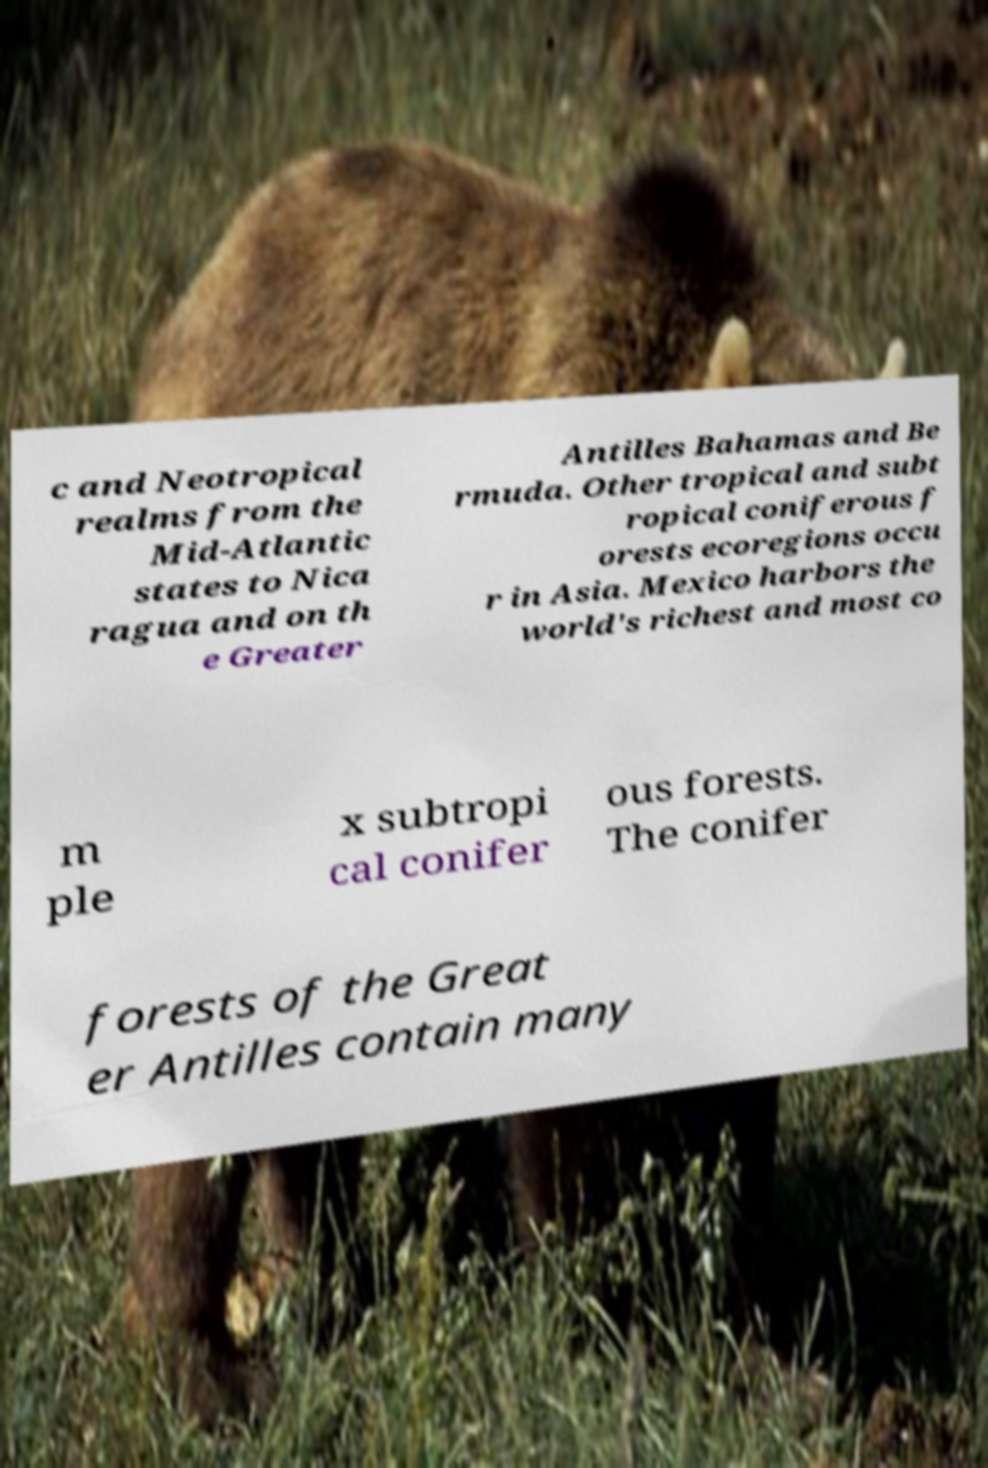Please identify and transcribe the text found in this image. c and Neotropical realms from the Mid-Atlantic states to Nica ragua and on th e Greater Antilles Bahamas and Be rmuda. Other tropical and subt ropical coniferous f orests ecoregions occu r in Asia. Mexico harbors the world's richest and most co m ple x subtropi cal conifer ous forests. The conifer forests of the Great er Antilles contain many 